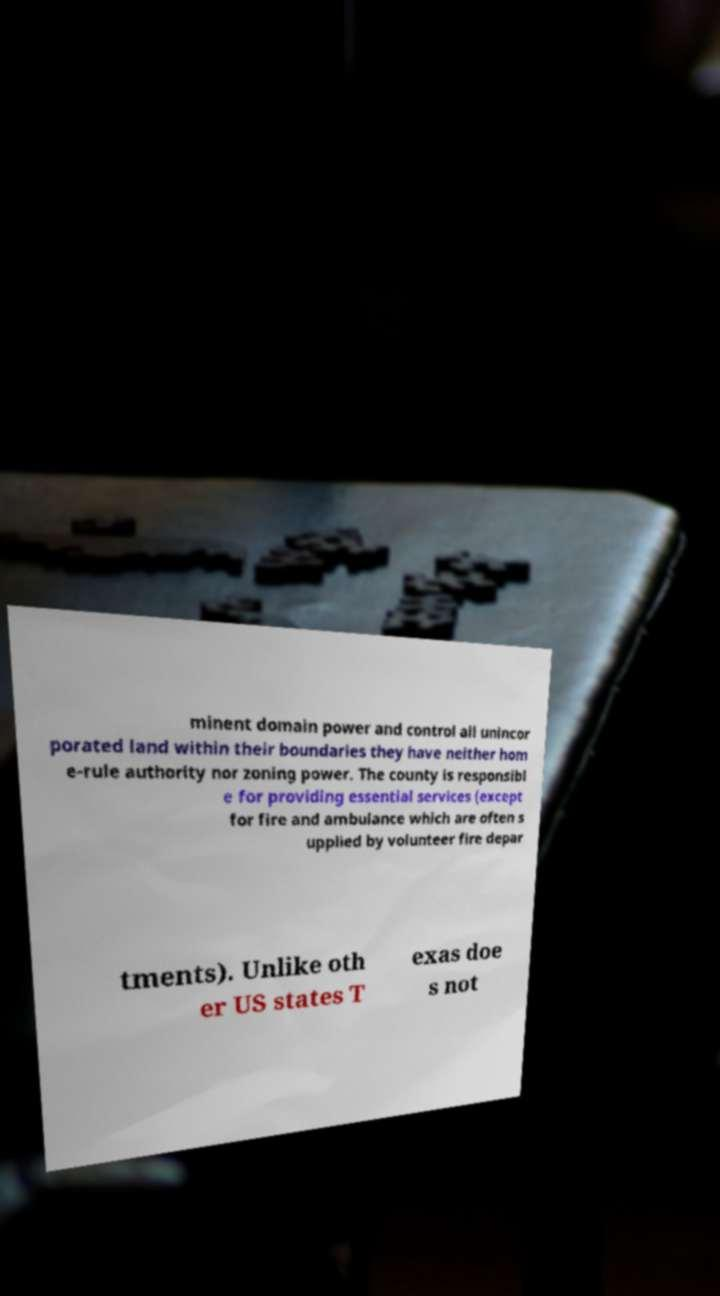Could you extract and type out the text from this image? minent domain power and control all unincor porated land within their boundaries they have neither hom e-rule authority nor zoning power. The county is responsibl e for providing essential services (except for fire and ambulance which are often s upplied by volunteer fire depar tments). Unlike oth er US states T exas doe s not 